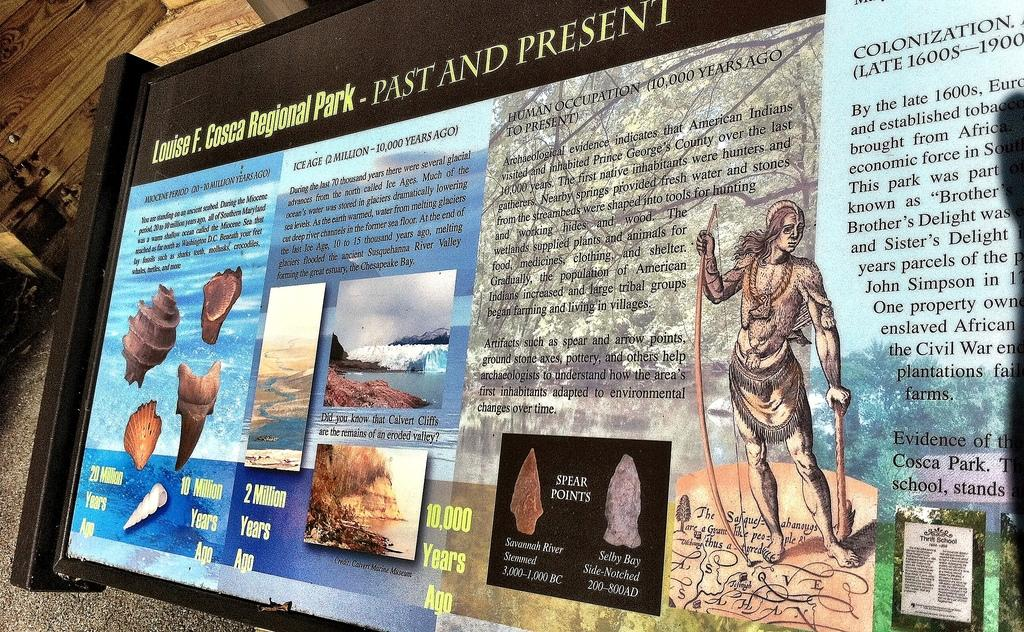<image>
Render a clear and concise summary of the photo. Info and history sign at Louis Cosca Regional Park in Princes George's County 